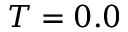Convert formula to latex. <formula><loc_0><loc_0><loc_500><loc_500>T = 0 . 0</formula> 